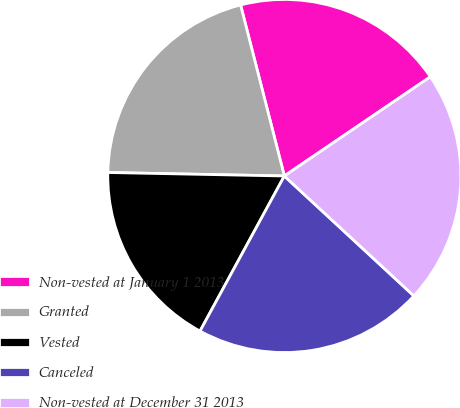Convert chart. <chart><loc_0><loc_0><loc_500><loc_500><pie_chart><fcel>Non-vested at January 1 2013<fcel>Granted<fcel>Vested<fcel>Canceled<fcel>Non-vested at December 31 2013<nl><fcel>19.49%<fcel>20.7%<fcel>17.39%<fcel>21.04%<fcel>21.38%<nl></chart> 